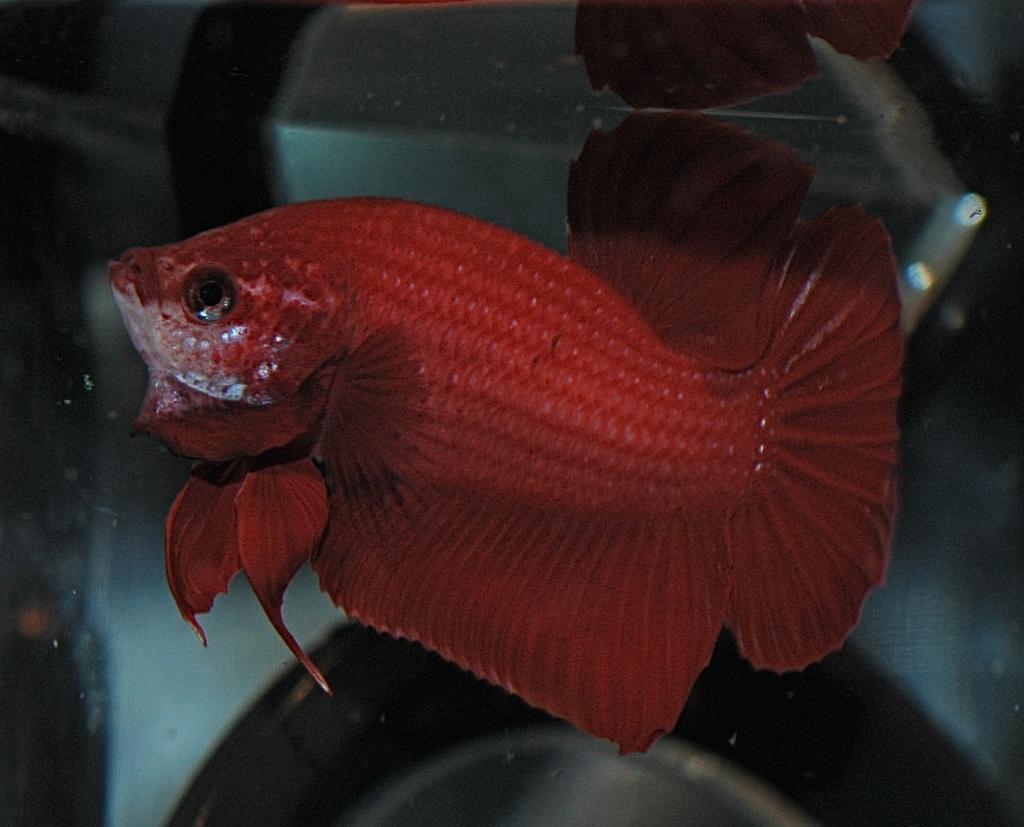Describe this image in one or two sentences. In this image there is a fish in the water. 